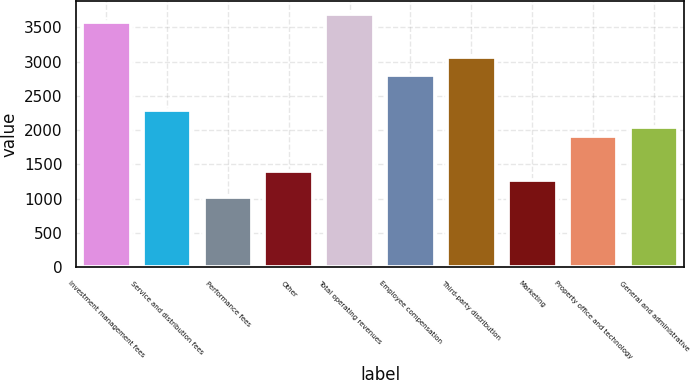Convert chart. <chart><loc_0><loc_0><loc_500><loc_500><bar_chart><fcel>Investment management fees<fcel>Service and distribution fees<fcel>Performance fees<fcel>Other<fcel>Total operating revenues<fcel>Employee compensation<fcel>Third-party distribution<fcel>Marketing<fcel>Property office and technology<fcel>General and administrative<nl><fcel>3574.32<fcel>2297.86<fcel>1021.42<fcel>1404.36<fcel>3701.97<fcel>2808.45<fcel>3063.74<fcel>1276.71<fcel>1914.93<fcel>2042.58<nl></chart> 